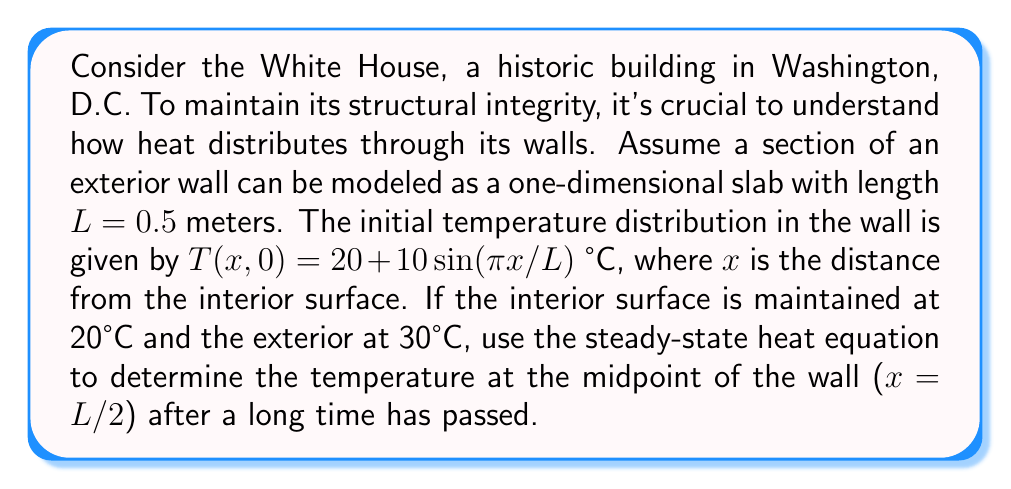What is the answer to this math problem? To solve this problem, we'll use the steady-state heat equation in one dimension:

$$\frac{d^2T}{dx^2} = 0$$

The general solution to this equation is:

$$T(x) = Ax + B$$

where A and B are constants determined by the boundary conditions.

Given:
1. At x = 0 (interior surface), T = 20°C
2. At x = L = 0.5m (exterior surface), T = 30°C

Applying these boundary conditions:

1. T(0) = B = 20°C
2. T(L) = AL + B = 30°C

Substituting the known values:

$$30 = A(0.5) + 20$$

Solving for A:

$$A = \frac{30 - 20}{0.5} = 20\text{ °C/m}$$

Therefore, the steady-state temperature distribution is:

$$T(x) = 20x + 20$$

To find the temperature at the midpoint (x = L/2 = 0.25m), we substitute this value:

$$T(0.25) = 20(0.25) + 20 = 25\text{ °C}$$

Note that the initial temperature distribution doesn't affect the steady-state solution, as the system will eventually reach equilibrium determined by the boundary conditions.
Answer: 25°C 